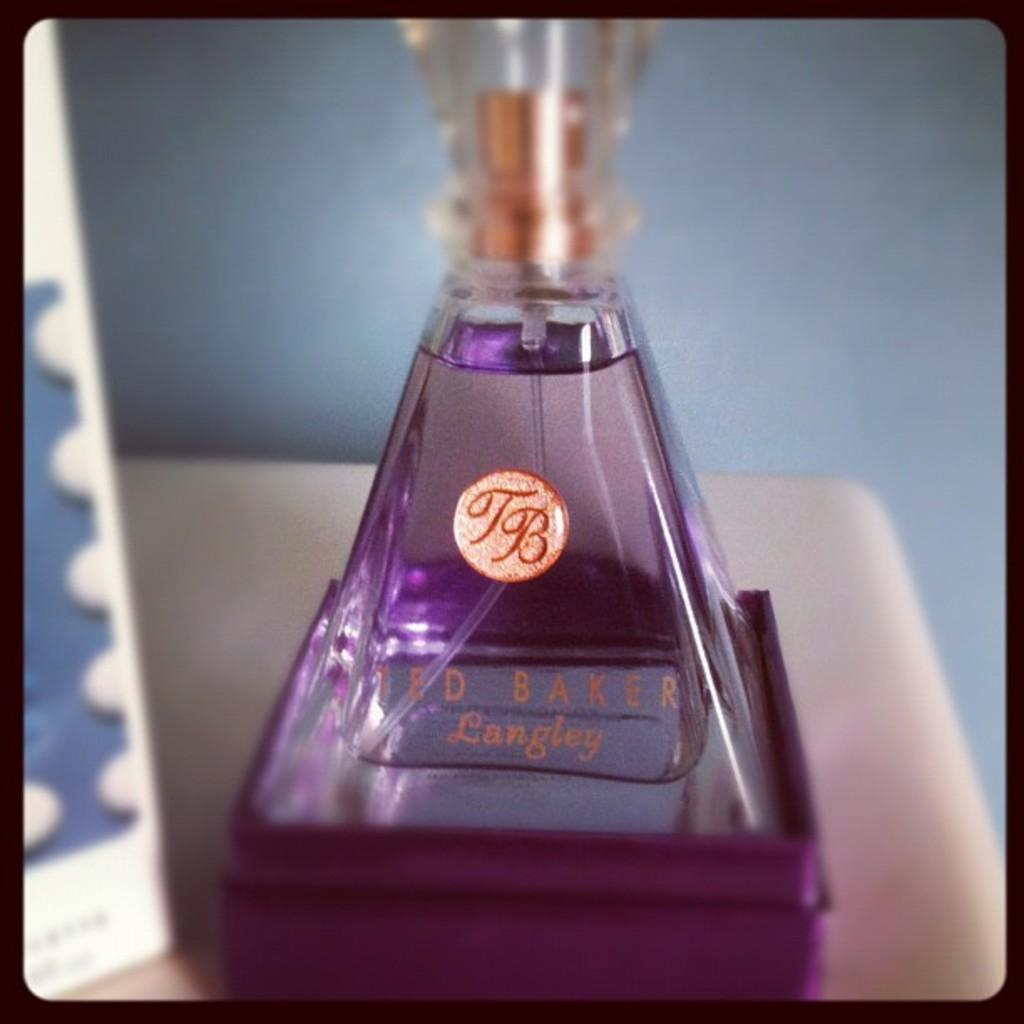<image>
Give a short and clear explanation of the subsequent image. A pyramid shaped perfume bottle says Ted Baker Langley. 